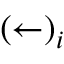<formula> <loc_0><loc_0><loc_500><loc_500>( \leftarrow ) _ { i }</formula> 